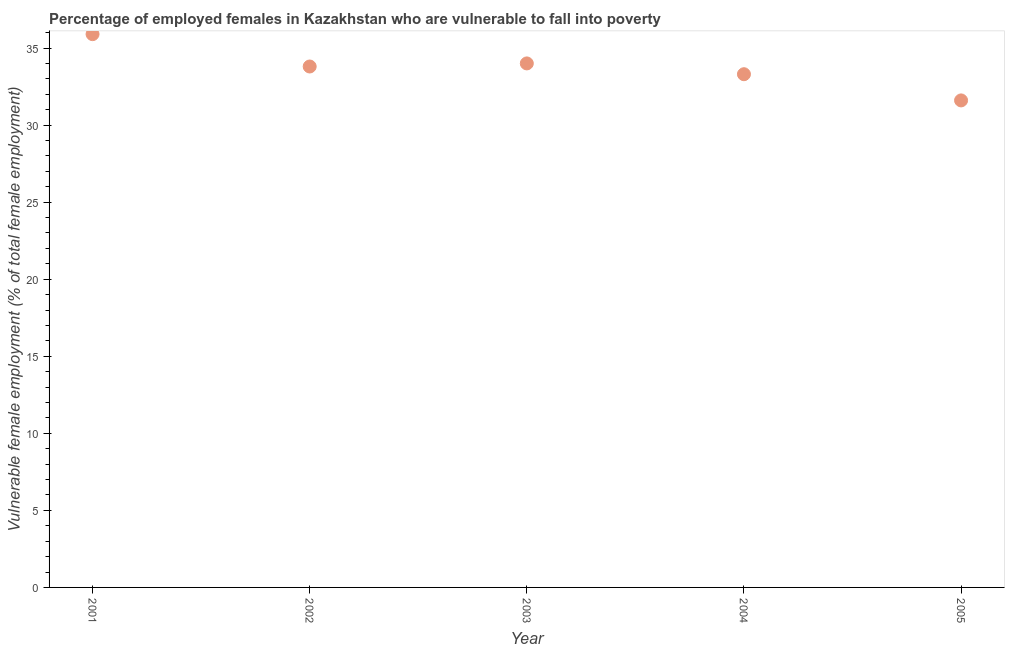What is the percentage of employed females who are vulnerable to fall into poverty in 2004?
Ensure brevity in your answer.  33.3. Across all years, what is the maximum percentage of employed females who are vulnerable to fall into poverty?
Your answer should be very brief. 35.9. Across all years, what is the minimum percentage of employed females who are vulnerable to fall into poverty?
Offer a terse response. 31.6. In which year was the percentage of employed females who are vulnerable to fall into poverty maximum?
Your answer should be very brief. 2001. In which year was the percentage of employed females who are vulnerable to fall into poverty minimum?
Ensure brevity in your answer.  2005. What is the sum of the percentage of employed females who are vulnerable to fall into poverty?
Your answer should be very brief. 168.6. What is the difference between the percentage of employed females who are vulnerable to fall into poverty in 2002 and 2003?
Provide a succinct answer. -0.2. What is the average percentage of employed females who are vulnerable to fall into poverty per year?
Make the answer very short. 33.72. What is the median percentage of employed females who are vulnerable to fall into poverty?
Offer a very short reply. 33.8. What is the ratio of the percentage of employed females who are vulnerable to fall into poverty in 2001 to that in 2002?
Make the answer very short. 1.06. Is the difference between the percentage of employed females who are vulnerable to fall into poverty in 2002 and 2005 greater than the difference between any two years?
Offer a very short reply. No. What is the difference between the highest and the second highest percentage of employed females who are vulnerable to fall into poverty?
Give a very brief answer. 1.9. What is the difference between the highest and the lowest percentage of employed females who are vulnerable to fall into poverty?
Your answer should be very brief. 4.3. In how many years, is the percentage of employed females who are vulnerable to fall into poverty greater than the average percentage of employed females who are vulnerable to fall into poverty taken over all years?
Keep it short and to the point. 3. Does the percentage of employed females who are vulnerable to fall into poverty monotonically increase over the years?
Offer a very short reply. No. How many years are there in the graph?
Provide a short and direct response. 5. What is the difference between two consecutive major ticks on the Y-axis?
Offer a very short reply. 5. What is the title of the graph?
Make the answer very short. Percentage of employed females in Kazakhstan who are vulnerable to fall into poverty. What is the label or title of the X-axis?
Make the answer very short. Year. What is the label or title of the Y-axis?
Make the answer very short. Vulnerable female employment (% of total female employment). What is the Vulnerable female employment (% of total female employment) in 2001?
Give a very brief answer. 35.9. What is the Vulnerable female employment (% of total female employment) in 2002?
Make the answer very short. 33.8. What is the Vulnerable female employment (% of total female employment) in 2004?
Provide a short and direct response. 33.3. What is the Vulnerable female employment (% of total female employment) in 2005?
Offer a very short reply. 31.6. What is the difference between the Vulnerable female employment (% of total female employment) in 2001 and 2004?
Give a very brief answer. 2.6. What is the difference between the Vulnerable female employment (% of total female employment) in 2001 and 2005?
Provide a short and direct response. 4.3. What is the difference between the Vulnerable female employment (% of total female employment) in 2002 and 2003?
Provide a succinct answer. -0.2. What is the difference between the Vulnerable female employment (% of total female employment) in 2002 and 2004?
Give a very brief answer. 0.5. What is the difference between the Vulnerable female employment (% of total female employment) in 2003 and 2004?
Your answer should be compact. 0.7. What is the difference between the Vulnerable female employment (% of total female employment) in 2004 and 2005?
Provide a succinct answer. 1.7. What is the ratio of the Vulnerable female employment (% of total female employment) in 2001 to that in 2002?
Keep it short and to the point. 1.06. What is the ratio of the Vulnerable female employment (% of total female employment) in 2001 to that in 2003?
Provide a succinct answer. 1.06. What is the ratio of the Vulnerable female employment (% of total female employment) in 2001 to that in 2004?
Offer a terse response. 1.08. What is the ratio of the Vulnerable female employment (% of total female employment) in 2001 to that in 2005?
Your answer should be compact. 1.14. What is the ratio of the Vulnerable female employment (% of total female employment) in 2002 to that in 2005?
Offer a terse response. 1.07. What is the ratio of the Vulnerable female employment (% of total female employment) in 2003 to that in 2004?
Keep it short and to the point. 1.02. What is the ratio of the Vulnerable female employment (% of total female employment) in 2003 to that in 2005?
Provide a short and direct response. 1.08. What is the ratio of the Vulnerable female employment (% of total female employment) in 2004 to that in 2005?
Offer a terse response. 1.05. 